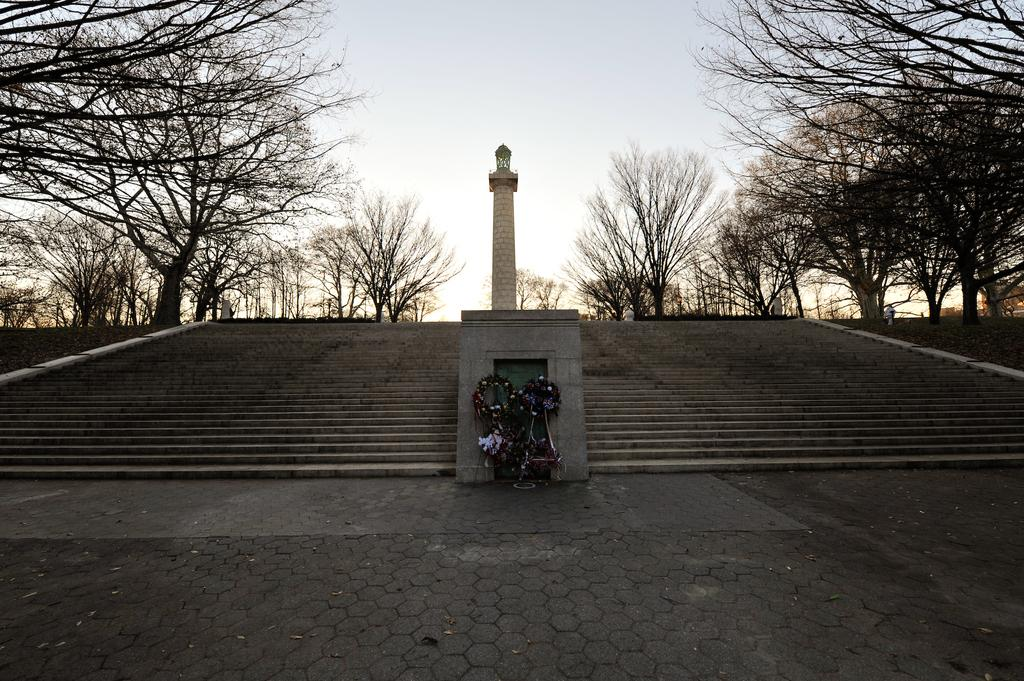What is the main structure in the middle of the image? There is a tower in the middle of the image. What can be seen besides the tower in the image? There are bouquets in the image. What architectural feature is present beside the tower? Steps are present beside the tower. What type of natural scenery is visible in the background of the image? There are trees in the background of the image. What type of skirt is the tower wearing in the image? The tower is not a person and therefore cannot wear a skirt. 